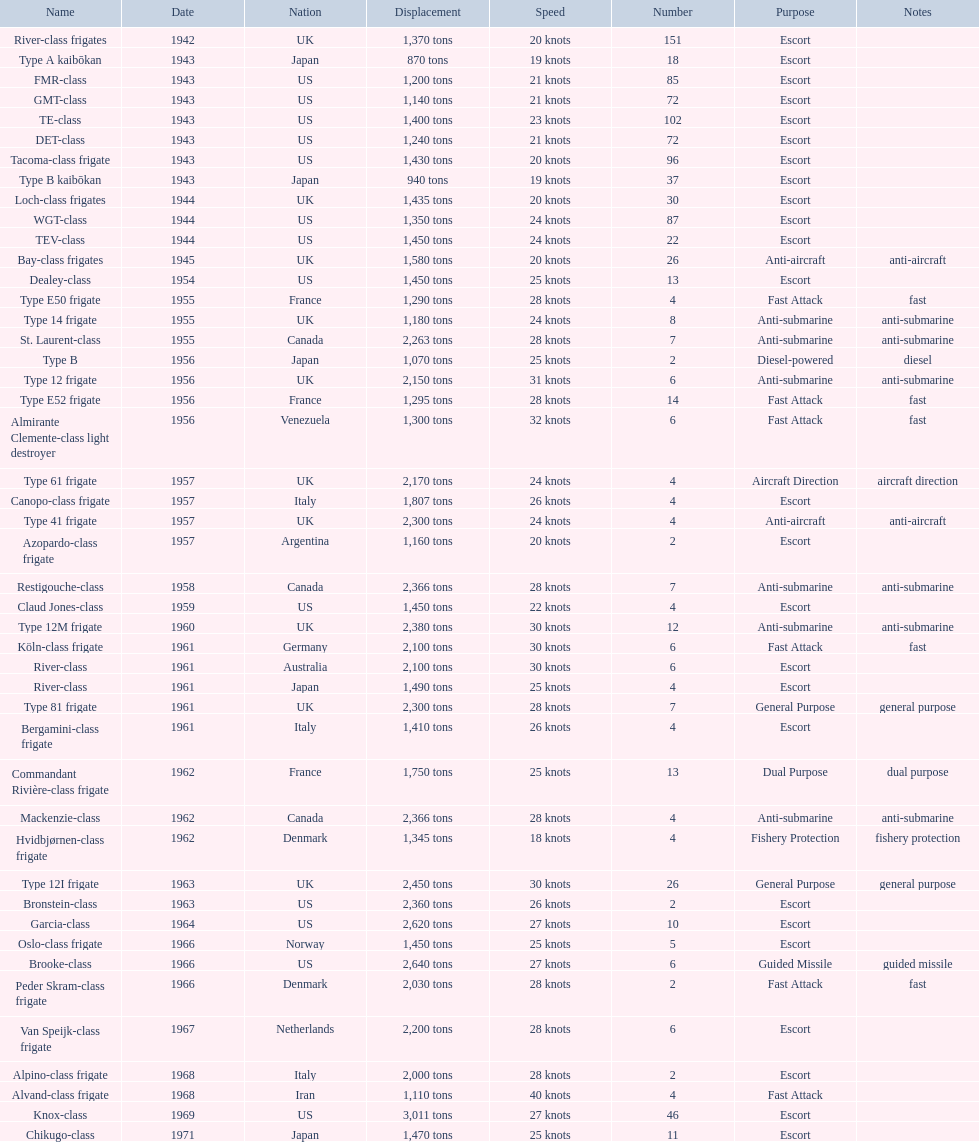How many consecutive escorts were in 1943? 7. 